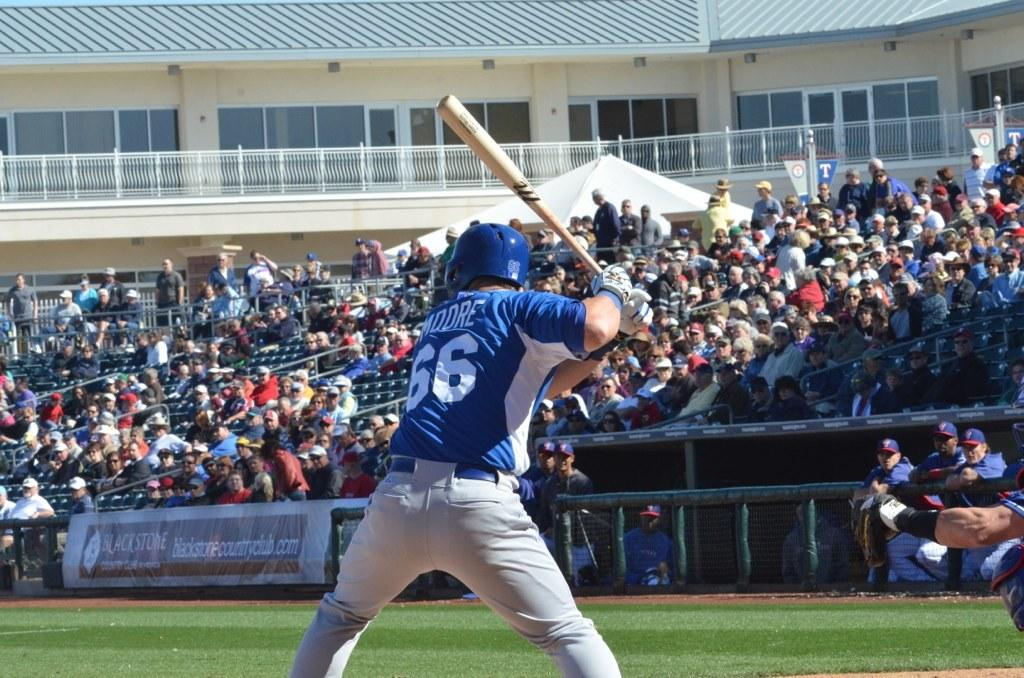<image>
Share a concise interpretation of the image provided. a banner from blackstone in front of a baseball player number 66 